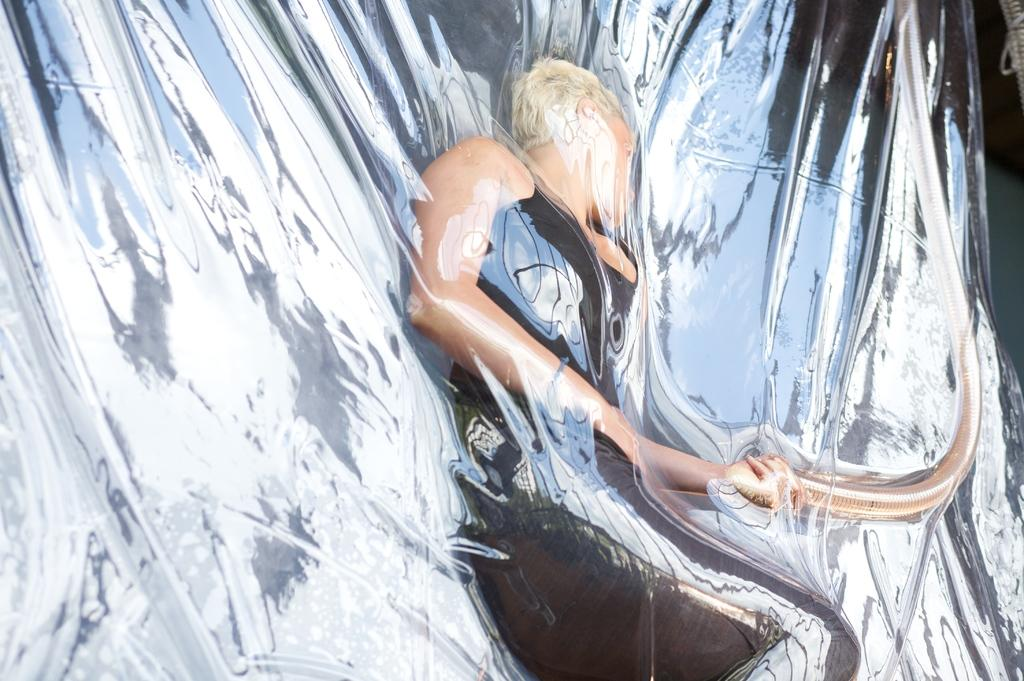What is present in the image? There is a person in the image. Can you describe the person's attire? The person is wearing black clothes. What type of toothbrush is the person using in the image? There is no toothbrush present in the image. What day of the week is indicated on the calendar in the image? There is no calendar present in the image. 